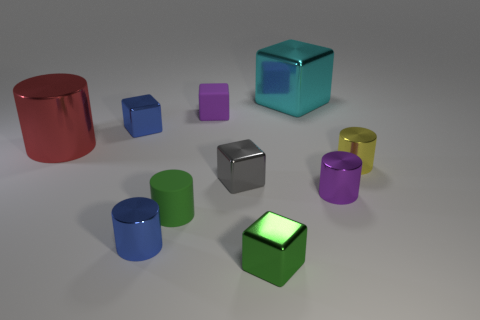Subtract all gray blocks. How many blocks are left? 4 Subtract all tiny purple metal cylinders. How many cylinders are left? 4 Subtract all brown cylinders. Subtract all blue cubes. How many cylinders are left? 5 Add 8 purple things. How many purple things exist? 10 Subtract 0 yellow cubes. How many objects are left? 10 Subtract all purple metallic cylinders. Subtract all small matte objects. How many objects are left? 7 Add 7 big cylinders. How many big cylinders are left? 8 